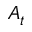<formula> <loc_0><loc_0><loc_500><loc_500>A _ { t }</formula> 